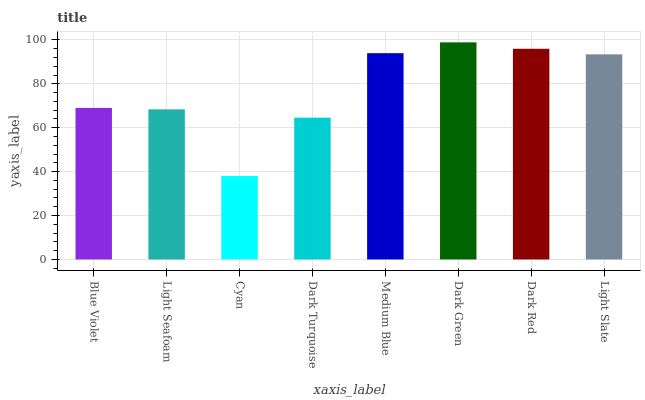Is Cyan the minimum?
Answer yes or no. Yes. Is Dark Green the maximum?
Answer yes or no. Yes. Is Light Seafoam the minimum?
Answer yes or no. No. Is Light Seafoam the maximum?
Answer yes or no. No. Is Blue Violet greater than Light Seafoam?
Answer yes or no. Yes. Is Light Seafoam less than Blue Violet?
Answer yes or no. Yes. Is Light Seafoam greater than Blue Violet?
Answer yes or no. No. Is Blue Violet less than Light Seafoam?
Answer yes or no. No. Is Light Slate the high median?
Answer yes or no. Yes. Is Blue Violet the low median?
Answer yes or no. Yes. Is Light Seafoam the high median?
Answer yes or no. No. Is Dark Red the low median?
Answer yes or no. No. 